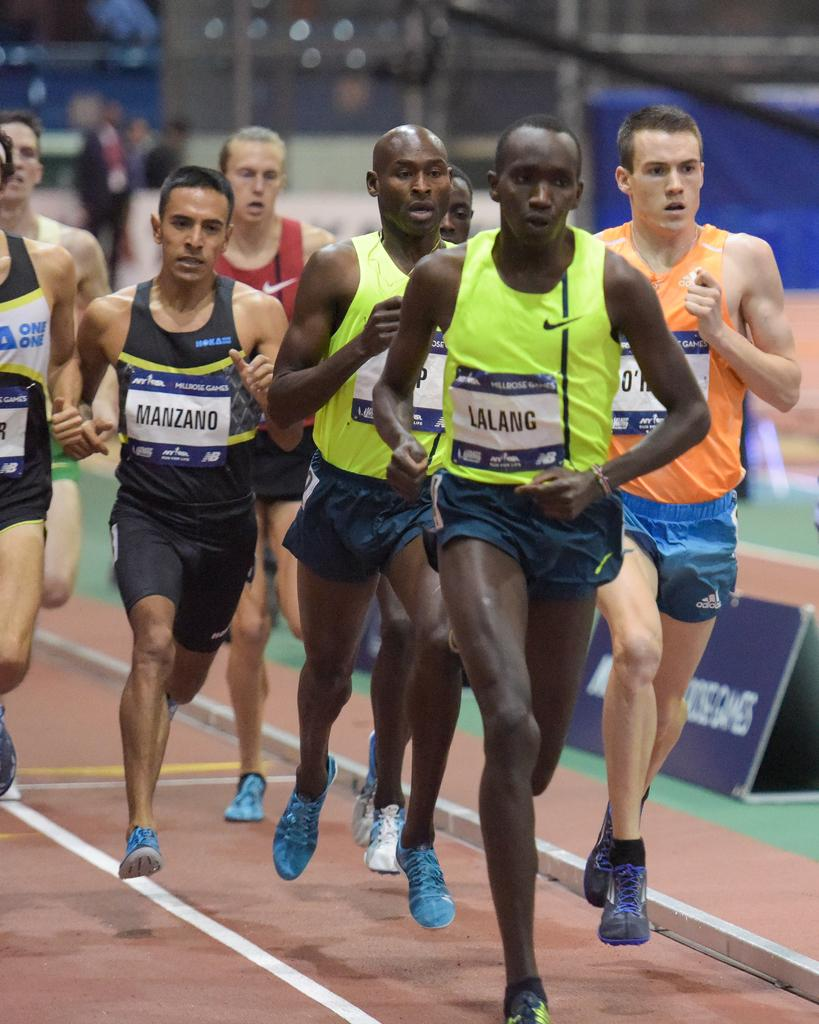<image>
Offer a succinct explanation of the picture presented. A group of men running on a track with the man at the lead wearing a sign that reads Lalang. 